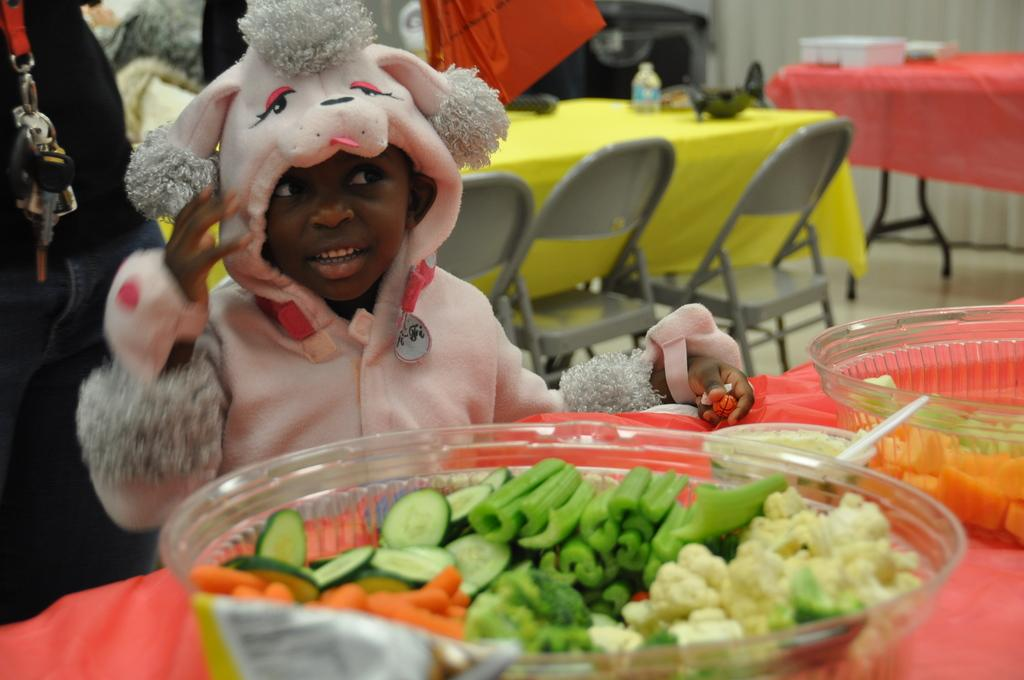What is in the bowl that is visible in the image? There are vegetables in a bowl in the image. Who is present in the image? A child is standing in the image. What type of furniture can be seen in the image? There are tables and chairs in the image. What is the bottle used for in the image? The purpose of the bottle is not clear from the image, but it is present. Can you hear the bell ringing in the image? There is no bell present in the image, so it cannot be heard. 